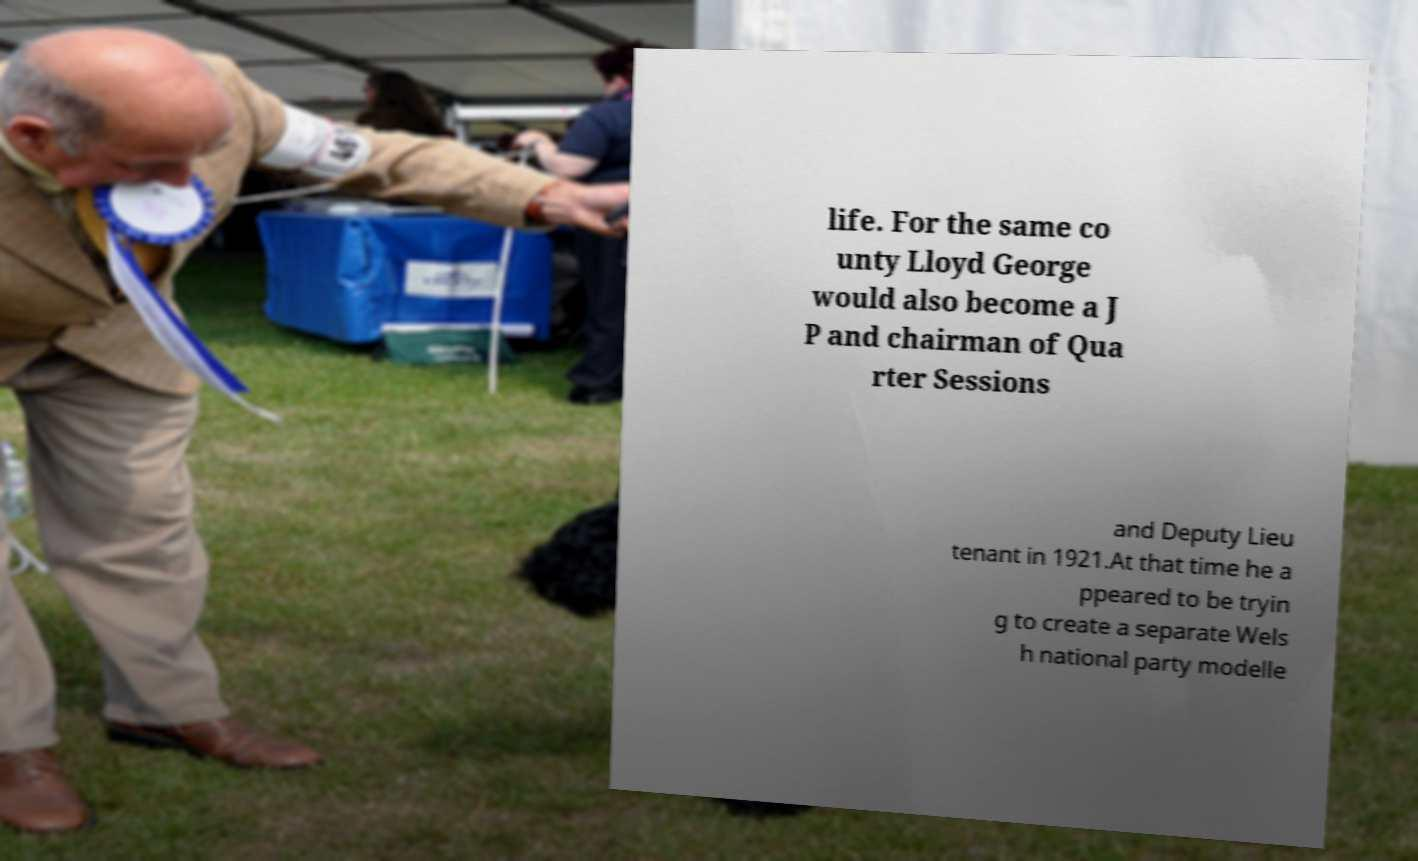Please identify and transcribe the text found in this image. life. For the same co unty Lloyd George would also become a J P and chairman of Qua rter Sessions and Deputy Lieu tenant in 1921.At that time he a ppeared to be tryin g to create a separate Wels h national party modelle 